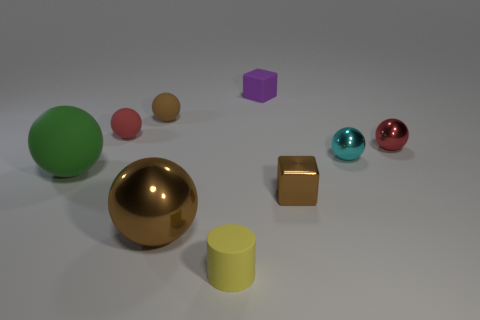Subtract all green spheres. How many spheres are left? 5 Subtract all cyan balls. How many balls are left? 5 Subtract all gray blocks. How many brown spheres are left? 2 Subtract 1 cylinders. How many cylinders are left? 0 Subtract all gray cylinders. Subtract all green balls. How many cylinders are left? 1 Subtract all small red blocks. Subtract all small brown rubber balls. How many objects are left? 8 Add 2 brown metallic balls. How many brown metallic balls are left? 3 Add 4 large brown shiny objects. How many large brown shiny objects exist? 5 Subtract 0 purple spheres. How many objects are left? 9 Subtract all spheres. How many objects are left? 3 